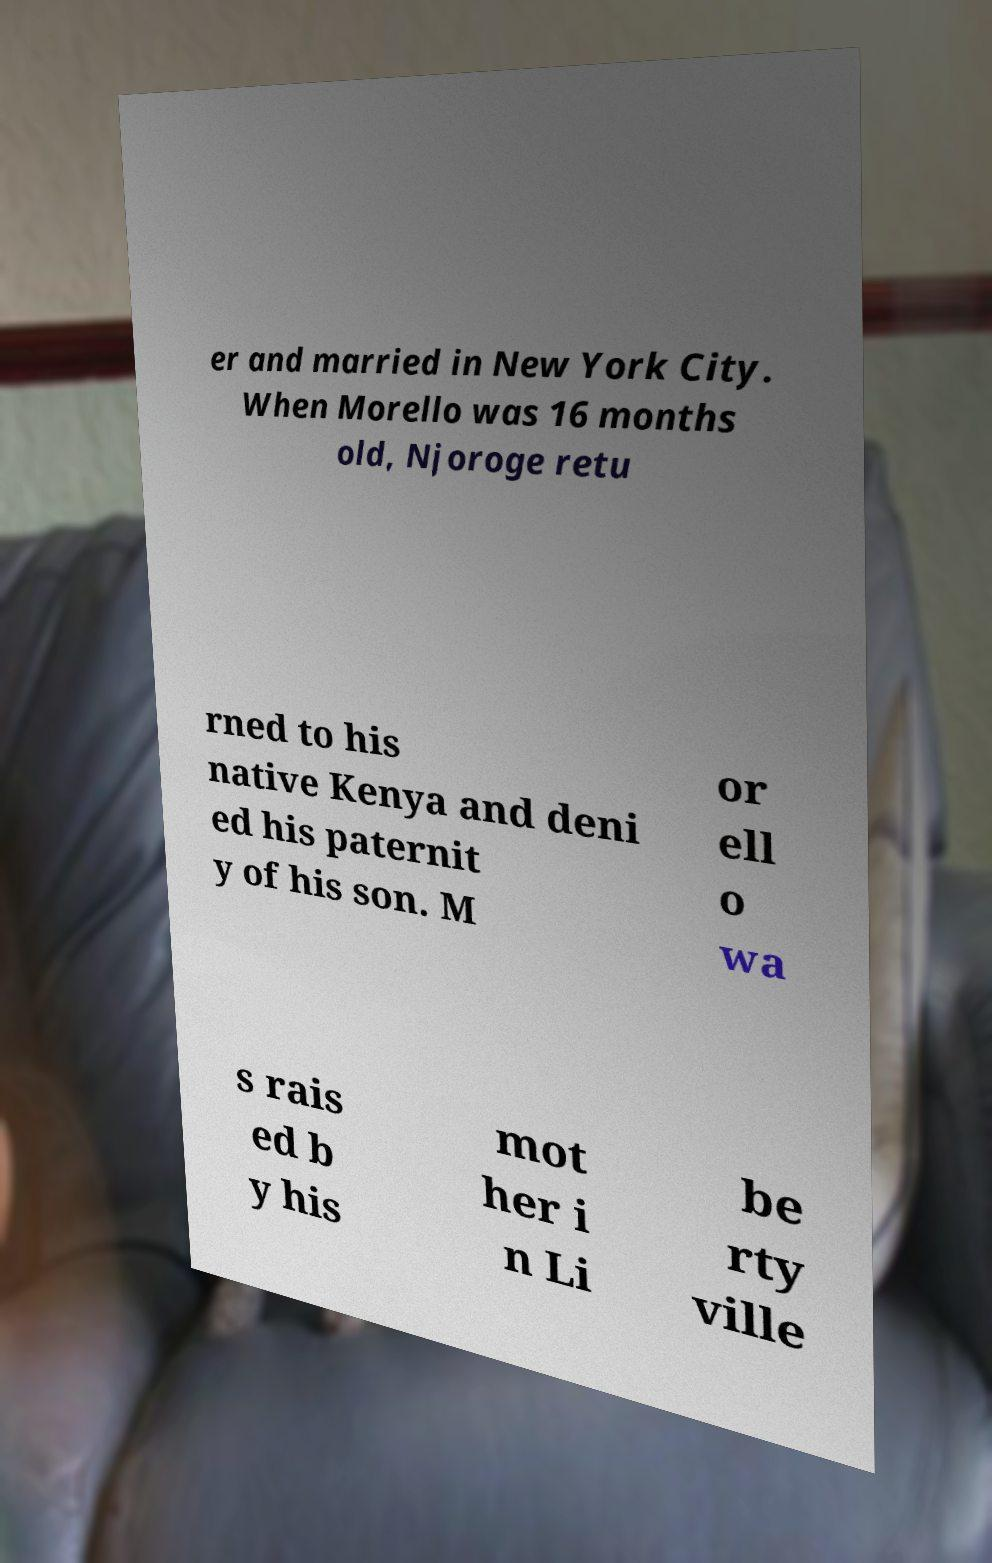I need the written content from this picture converted into text. Can you do that? er and married in New York City. When Morello was 16 months old, Njoroge retu rned to his native Kenya and deni ed his paternit y of his son. M or ell o wa s rais ed b y his mot her i n Li be rty ville 